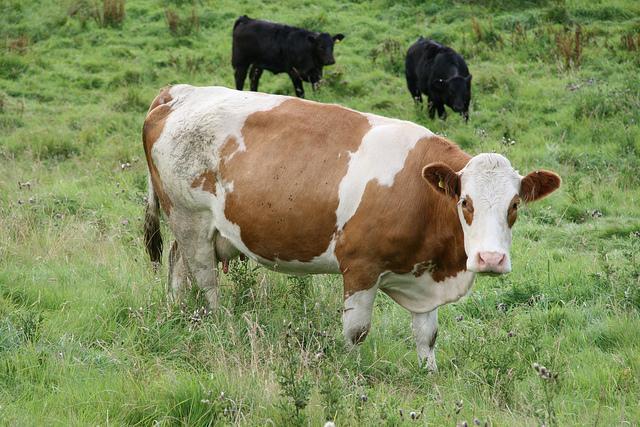How many cows can be seen?
Give a very brief answer. 3. How many books are stacked in the front?
Give a very brief answer. 0. 